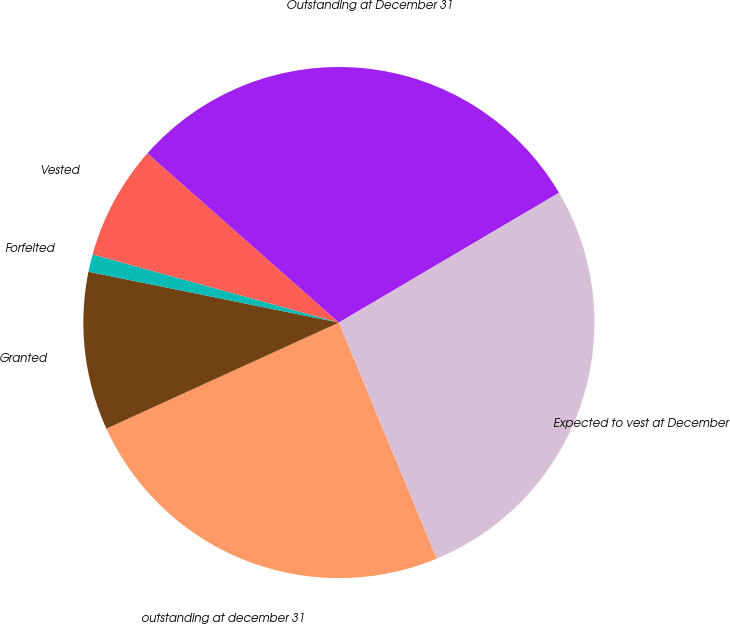Convert chart to OTSL. <chart><loc_0><loc_0><loc_500><loc_500><pie_chart><fcel>outstanding at december 31<fcel>Granted<fcel>Forfeited<fcel>Vested<fcel>Outstanding at December 31<fcel>Expected to vest at December<nl><fcel>24.44%<fcel>10.0%<fcel>1.11%<fcel>7.22%<fcel>30.0%<fcel>27.22%<nl></chart> 